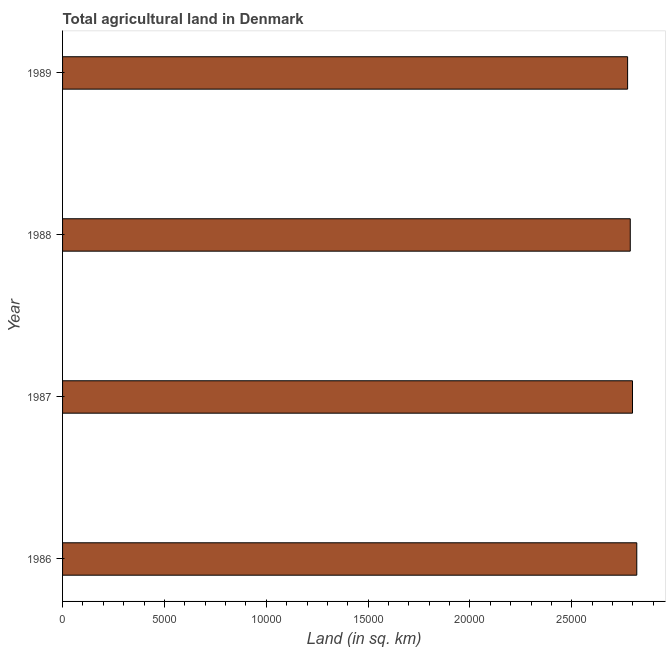Does the graph contain any zero values?
Make the answer very short. No. Does the graph contain grids?
Ensure brevity in your answer.  No. What is the title of the graph?
Give a very brief answer. Total agricultural land in Denmark. What is the label or title of the X-axis?
Offer a terse response. Land (in sq. km). What is the agricultural land in 1987?
Keep it short and to the point. 2.80e+04. Across all years, what is the maximum agricultural land?
Make the answer very short. 2.82e+04. Across all years, what is the minimum agricultural land?
Your response must be concise. 2.77e+04. In which year was the agricultural land minimum?
Provide a short and direct response. 1989. What is the sum of the agricultural land?
Keep it short and to the point. 1.12e+05. What is the difference between the agricultural land in 1988 and 1989?
Make the answer very short. 130. What is the average agricultural land per year?
Offer a very short reply. 2.79e+04. What is the median agricultural land?
Your answer should be compact. 2.79e+04. In how many years, is the agricultural land greater than 20000 sq. km?
Provide a short and direct response. 4. What is the difference between the highest and the second highest agricultural land?
Your answer should be very brief. 210. What is the difference between the highest and the lowest agricultural land?
Your answer should be compact. 450. In how many years, is the agricultural land greater than the average agricultural land taken over all years?
Give a very brief answer. 2. How many bars are there?
Keep it short and to the point. 4. What is the Land (in sq. km) in 1986?
Your answer should be compact. 2.82e+04. What is the Land (in sq. km) in 1987?
Offer a terse response. 2.80e+04. What is the Land (in sq. km) of 1988?
Your answer should be very brief. 2.79e+04. What is the Land (in sq. km) in 1989?
Offer a very short reply. 2.77e+04. What is the difference between the Land (in sq. km) in 1986 and 1987?
Make the answer very short. 210. What is the difference between the Land (in sq. km) in 1986 and 1988?
Provide a short and direct response. 320. What is the difference between the Land (in sq. km) in 1986 and 1989?
Provide a succinct answer. 450. What is the difference between the Land (in sq. km) in 1987 and 1988?
Make the answer very short. 110. What is the difference between the Land (in sq. km) in 1987 and 1989?
Your answer should be compact. 240. What is the difference between the Land (in sq. km) in 1988 and 1989?
Offer a terse response. 130. What is the ratio of the Land (in sq. km) in 1986 to that in 1987?
Make the answer very short. 1.01. What is the ratio of the Land (in sq. km) in 1986 to that in 1989?
Give a very brief answer. 1.02. What is the ratio of the Land (in sq. km) in 1987 to that in 1988?
Make the answer very short. 1. What is the ratio of the Land (in sq. km) in 1987 to that in 1989?
Your response must be concise. 1.01. What is the ratio of the Land (in sq. km) in 1988 to that in 1989?
Your answer should be compact. 1. 